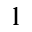Convert formula to latex. <formula><loc_0><loc_0><loc_500><loc_500>^ { 1 }</formula> 